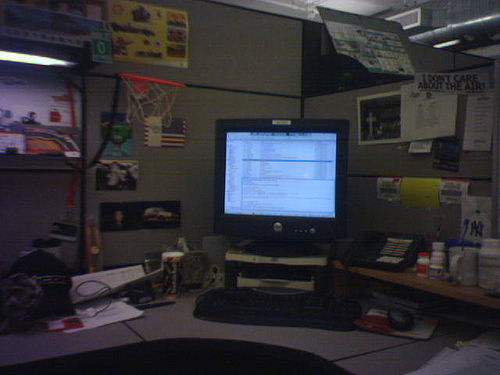<image>What product is being advertised in the background? I don't know what product is being advertised in the background. It is unspecified. What is on the floor with a handle? It is unknown what is on the floor with a handle. It could be a chair, a dustpan, a mouse or a cup. What sports equipment is here? I am not sure what sports equipment is in the image, but it could be a basketball hoop. What product is being advertised in the background? It is unknown what product is being advertised in the background. What is on the floor with a handle? It is ambiguous what is on the floor with a handle. It can be seen 'chair', 'dustpan', 'mouse' or 'cup'. What sports equipment is here? I am not sure what sports equipment is here. It can be seen a basketball hoop or a basketball goal. 